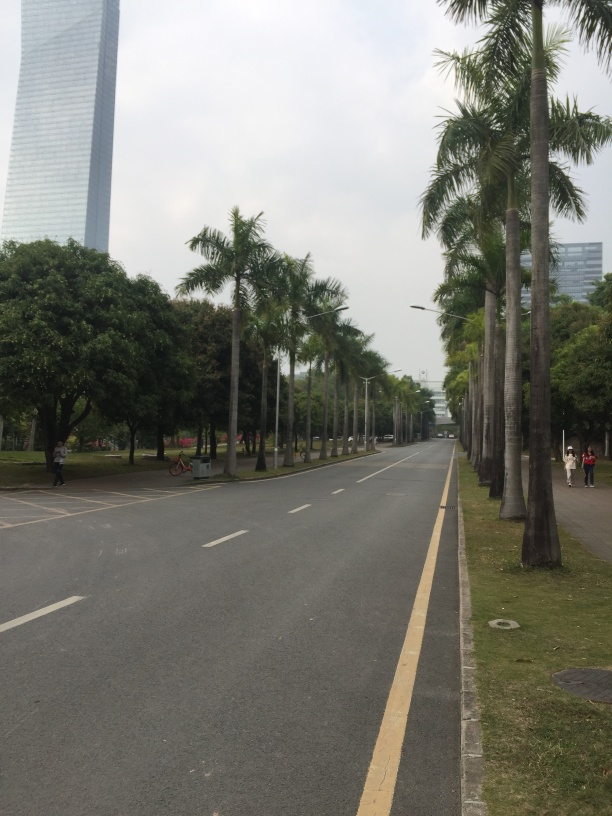What could be the purpose of this area? This area appears to be a well-maintained urban street that could serve a few purposes. It looks like it could be a main thoroughfare that accommodates vehicles between significant parts of the city. Given the wide sidewalks and presence of palm trees, it also suggests the area is designed for pedestrian use, offering a space for walking or jogging alongside the vehicle road. 